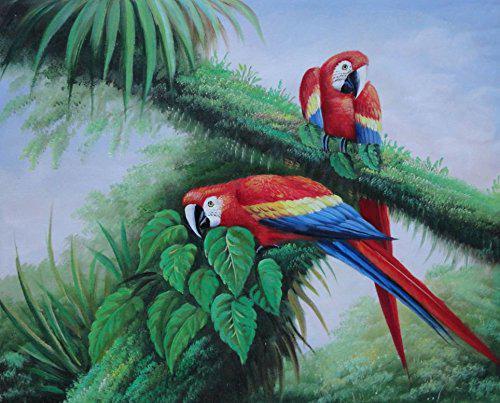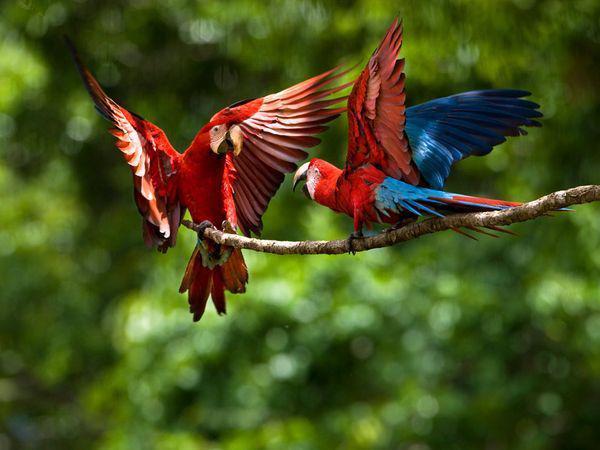The first image is the image on the left, the second image is the image on the right. Given the left and right images, does the statement "The right image contains exactly two parrots." hold true? Answer yes or no. Yes. The first image is the image on the left, the second image is the image on the right. For the images displayed, is the sentence "The combined images contain no more than four parrots, and include a parrot with a green head and body." factually correct? Answer yes or no. No. 